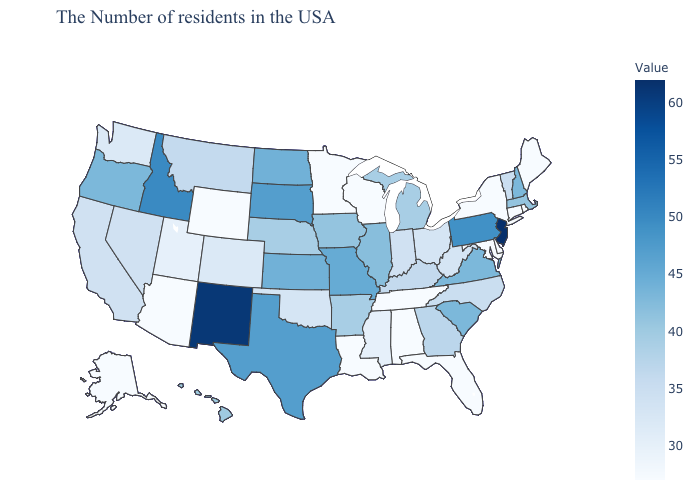Which states hav the highest value in the South?
Write a very short answer. Texas. Among the states that border Wisconsin , does Illinois have the highest value?
Concise answer only. Yes. Among the states that border South Dakota , does North Dakota have the lowest value?
Concise answer only. No. Does New Mexico have a higher value than Louisiana?
Write a very short answer. Yes. Does New Hampshire have the lowest value in the USA?
Write a very short answer. No. Which states have the highest value in the USA?
Keep it brief. New Jersey. 